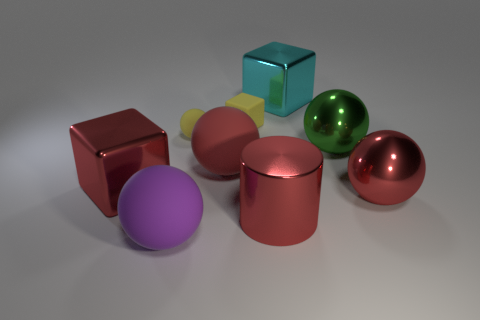Subtract all large balls. How many balls are left? 1 Subtract all purple spheres. How many spheres are left? 4 Subtract all blue spheres. Subtract all yellow blocks. How many spheres are left? 5 Add 1 brown cylinders. How many objects exist? 10 Subtract all cylinders. How many objects are left? 8 Subtract all large blocks. Subtract all cyan metallic things. How many objects are left? 6 Add 5 large matte spheres. How many large matte spheres are left? 7 Add 6 cylinders. How many cylinders exist? 7 Subtract 0 cyan balls. How many objects are left? 9 